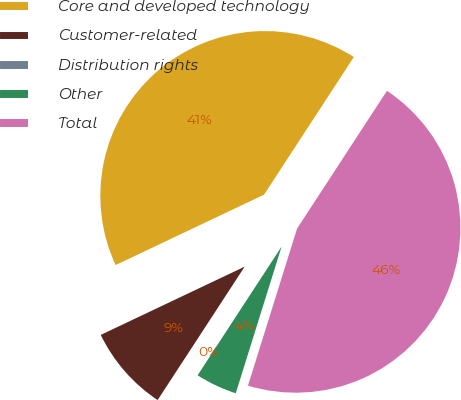<chart> <loc_0><loc_0><loc_500><loc_500><pie_chart><fcel>Core and developed technology<fcel>Customer-related<fcel>Distribution rights<fcel>Other<fcel>Total<nl><fcel>41.25%<fcel>8.75%<fcel>0.0%<fcel>4.38%<fcel>45.62%<nl></chart> 